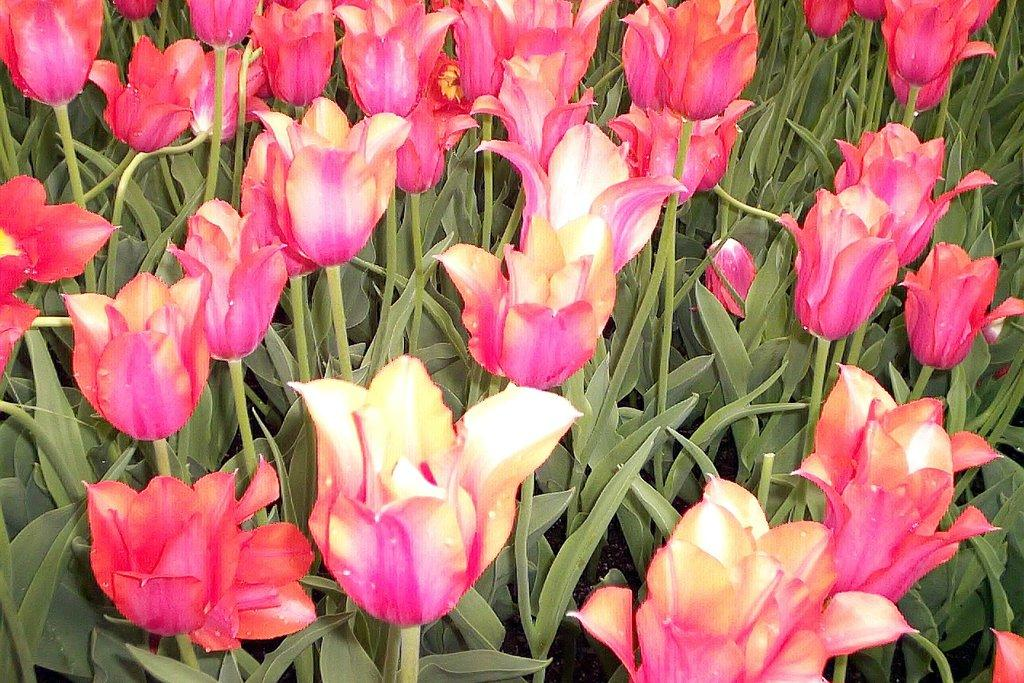What is the main subject of the image? The main subject of the image is plants. What specific features do the plants have? The plants have flowers and leaves. What type of ball can be seen in the image? There is no ball present in the image; it features plants with flowers and leaves. How are the plants distributed in the image? The plants are located in the center of the image, but there is no information about their distribution within that area. 